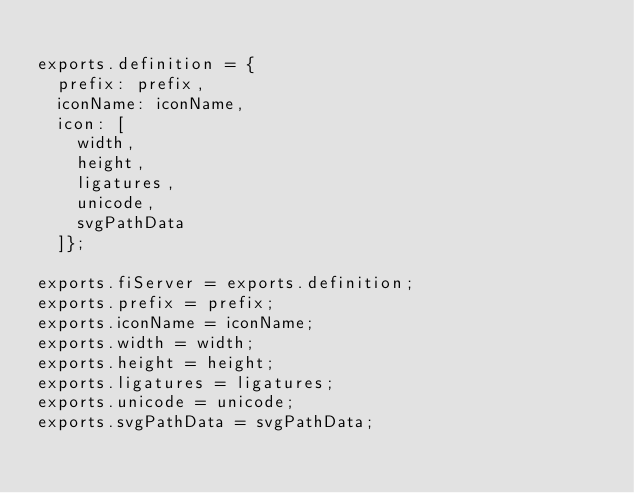<code> <loc_0><loc_0><loc_500><loc_500><_JavaScript_>
exports.definition = {
  prefix: prefix,
  iconName: iconName,
  icon: [
    width,
    height,
    ligatures,
    unicode,
    svgPathData
  ]};
	
exports.fiServer = exports.definition;
exports.prefix = prefix;
exports.iconName = iconName;
exports.width = width;
exports.height = height;
exports.ligatures = ligatures;
exports.unicode = unicode;
exports.svgPathData = svgPathData;</code> 